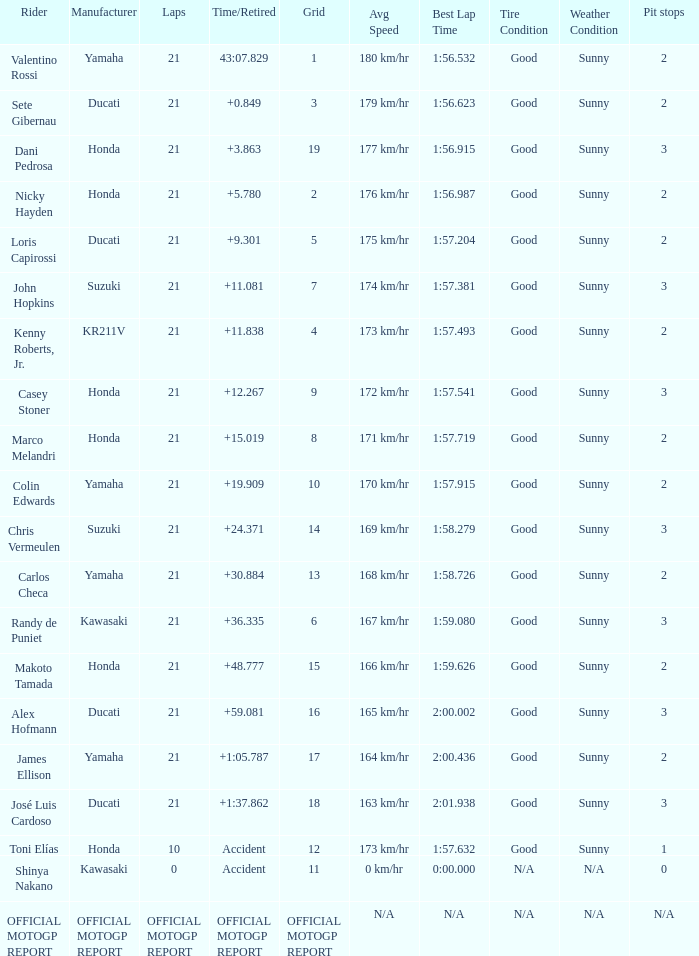How many laps did Valentino rossi have when riding a vehicle manufactured by yamaha? 21.0. 